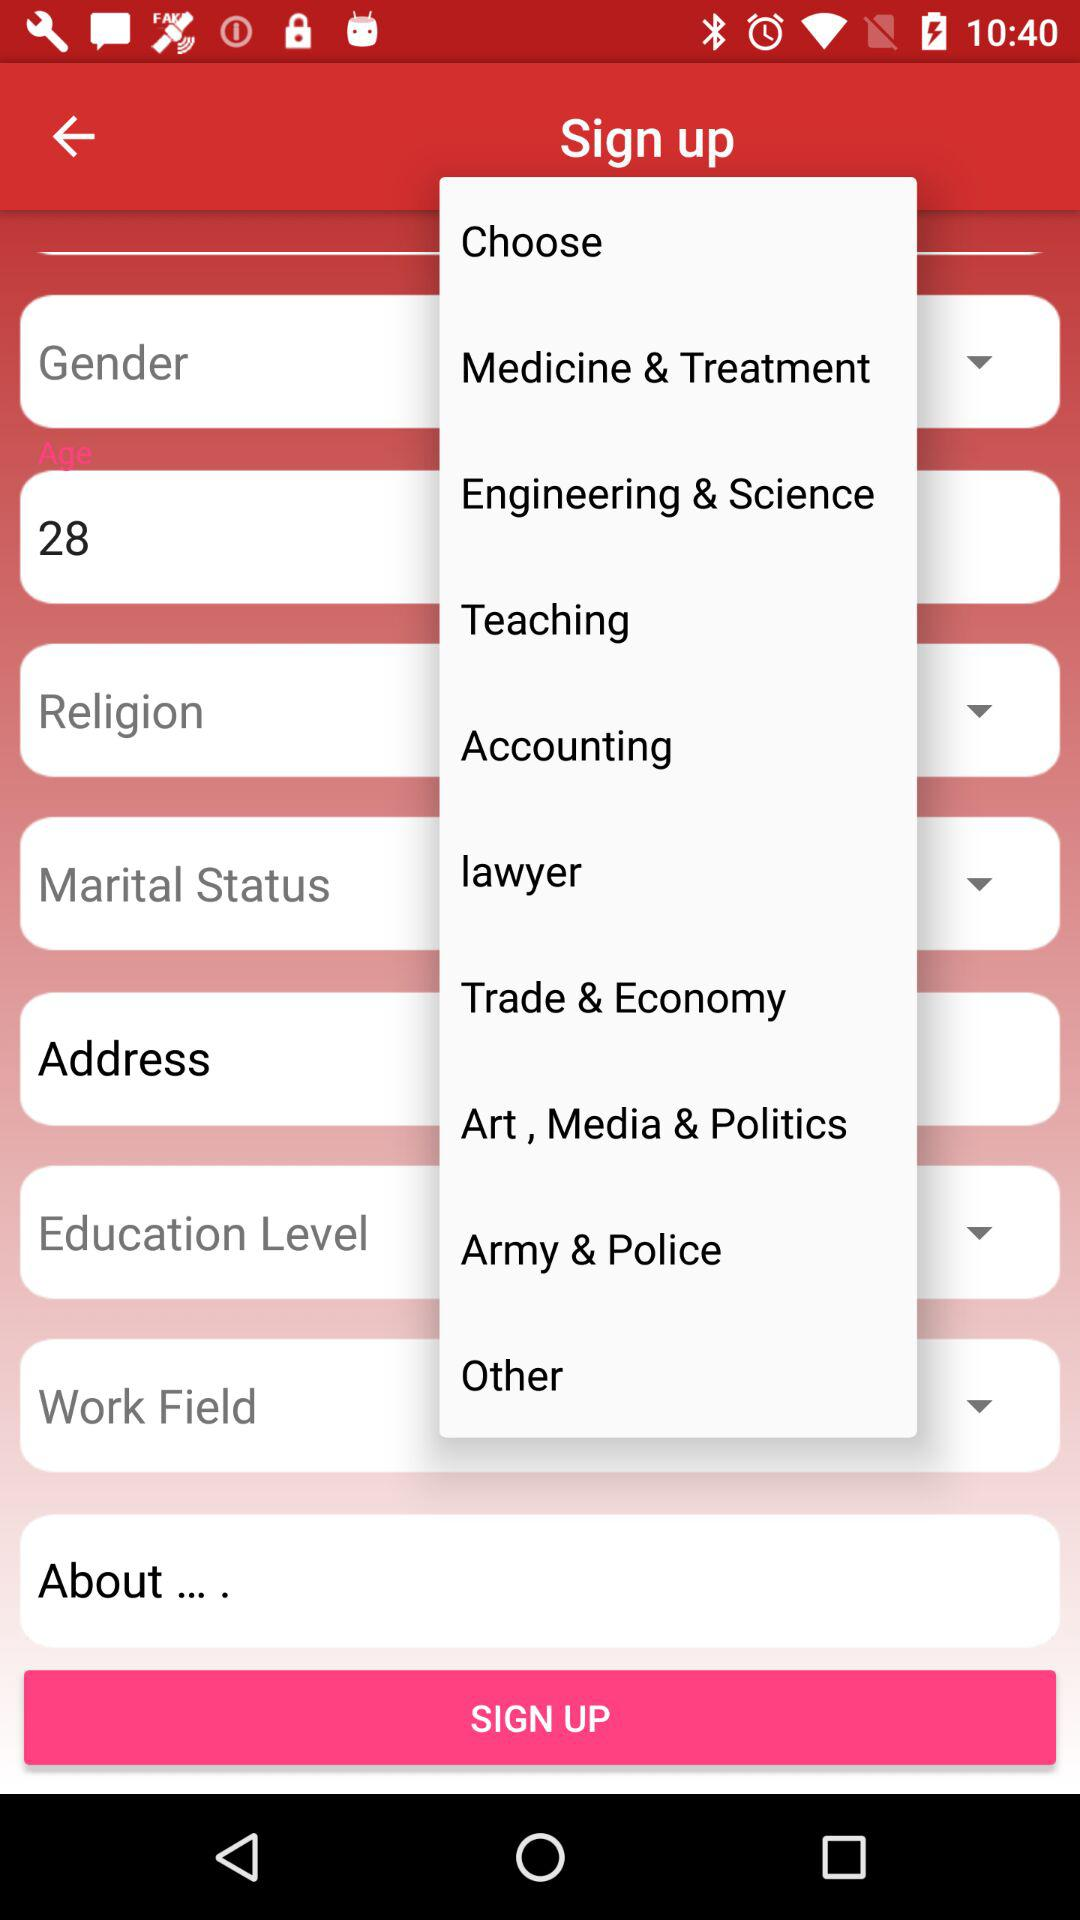What's the age? The age is 28 years old. 